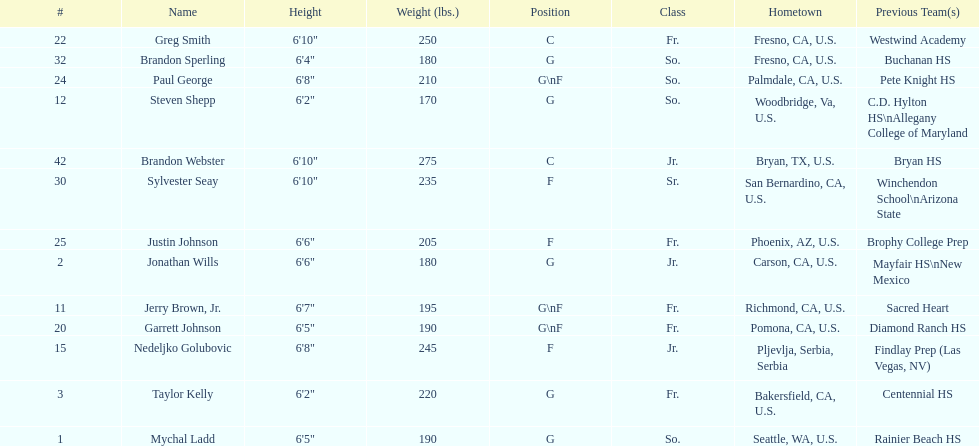Taylor kelly has a height less than 6' 3", which additional player is also below 6' 3"? Steven Shepp. 